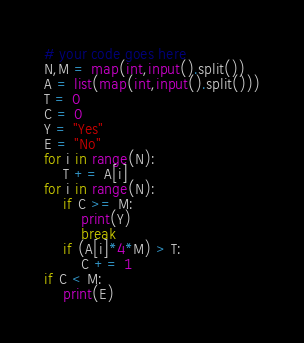<code> <loc_0><loc_0><loc_500><loc_500><_Python_># your code goes here
N,M = map(int,input().split())
A = list(map(int,input().split()))
T = 0
C = 0
Y = "Yes"
E = "No"
for i in range(N):
    T += A[i]
for i in range(N):
    if C >= M:
        print(Y)
        break
    if (A[i]*4*M) > T:
        C += 1
if C < M:
    print(E)</code> 